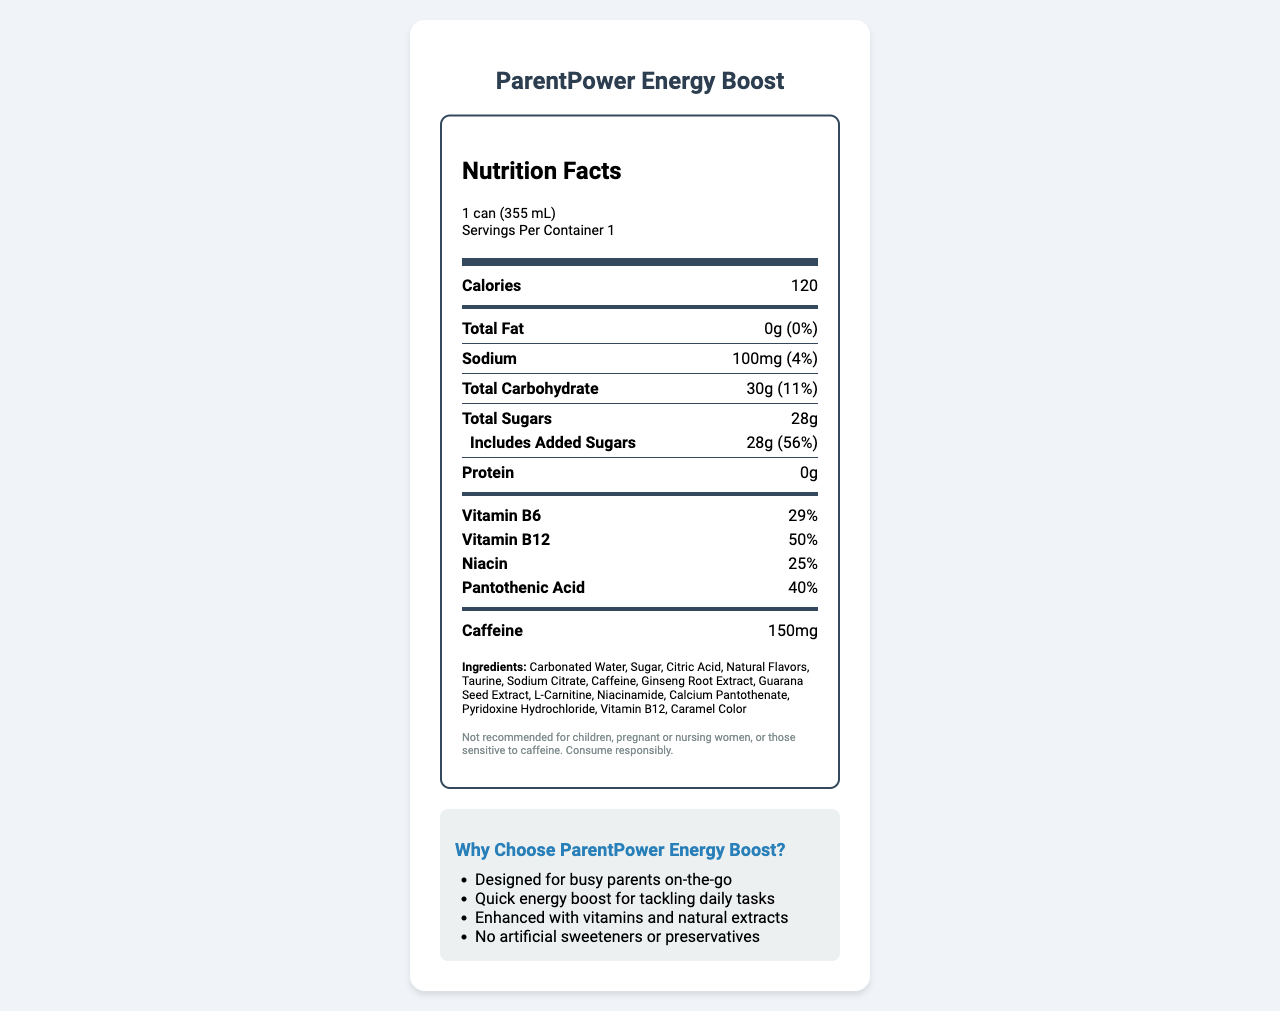What is the serving size for ParentPower Energy Boost? The serving size is clearly mentioned in the document as 1 can (355 mL).
Answer: 1 can (355 mL) How many calories are there per serving? The document states that there are 120 calories per serving.
Answer: 120 What is the total amount of fat in ParentPower Energy Boost? The total fat content is listed as 0g in the nutrition facts.
Answer: 0g How much sodium is in one can of this energy drink? The sodium content per serving is listed as 100mg.
Answer: 100mg What percentage of daily value of Vitamin B6 does ParentPower Energy Boost provide? The document shows that one can provides 29% of the daily value for Vitamin B6.
Answer: 29% Which of the following ingredients is NOT listed in ParentPower Energy Boost? 
1. Citric Acid
2. Aspartame
3. Guarana Seed Extract
4. Caramel Color The ingredients listed in the document include Citric Acid, Guarana Seed Extract, and Caramel Color but not Aspartame.
Answer: 2. Aspartame For which group of people is the consumption of ParentPower Energy Boost NOT recommended? 
A. Children
B. Athletes
C. Busy Parents
D. Pregnant Women The disclaimer section advises that the drink is not recommended for children, pregnant or nursing women, or those sensitive to caffeine.
Answer: A. Children; D. Pregnant Women Does ParentPower Energy Boost contain any protein? The nutrition facts state that the protein content is 0g.
Answer: No Is there any information on how to store ParentPower Energy Boost after opening? The document states to refrigerate after opening and consume within 24 hours.
Answer: Yes Can ParentPower Energy Boost be consumed by individuals who are not sensitive to caffeine? According to the disclaimer, it is recommended to be consumed responsibly, but it is not prohibited for those not sensitive to caffeine.
Answer: Yes Summarize the main idea of the document. The document provides comprehensive information about an energy drink aimed at busy parents, its nutritional content, special ingredients, and usage instructions, alongside cautionary advice and marketing points.
Answer: The document is a nutrition facts label for "ParentPower Energy Boost," an energy drink designed for active parents. It provides information on serving size, calorie content, macronutrients, vitamins, and specific ingredients like caffeine, taurine, and various extracts. It includes allergen information, storage instructions, and marketing claims highlighting its benefits and target audience. What is the exact amount of caffeine in one serving of ParentPower Energy Boost? The document specifies that there are 150mg of caffeine per serving.
Answer: 150mg How many grams of added sugars are included in the total sugar content? The document shows that all 28g of the total sugars are added sugars.
Answer: 28g Is ParentPower Energy Boost suitable for those with milk allergies? The document states it is produced in a facility that processes milk, but it does not specify if it is safe for milk allergy sufferers.
Answer: Not enough information How does ParentPower Energy Boost claim to benefit busy parents? The marketing claims list "Quick energy boost for tackling daily tasks" as one of the benefits for busy parents.
Answer: Quick energy boost for tackling daily tasks 